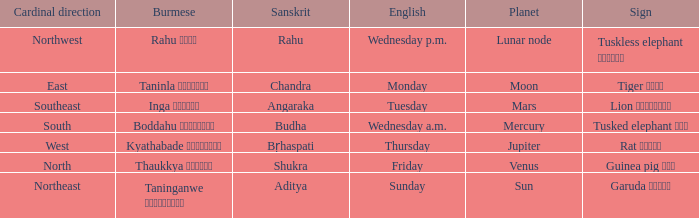What is the Burmese term for Thursday? Kyathabade ကြာသပတေး. 